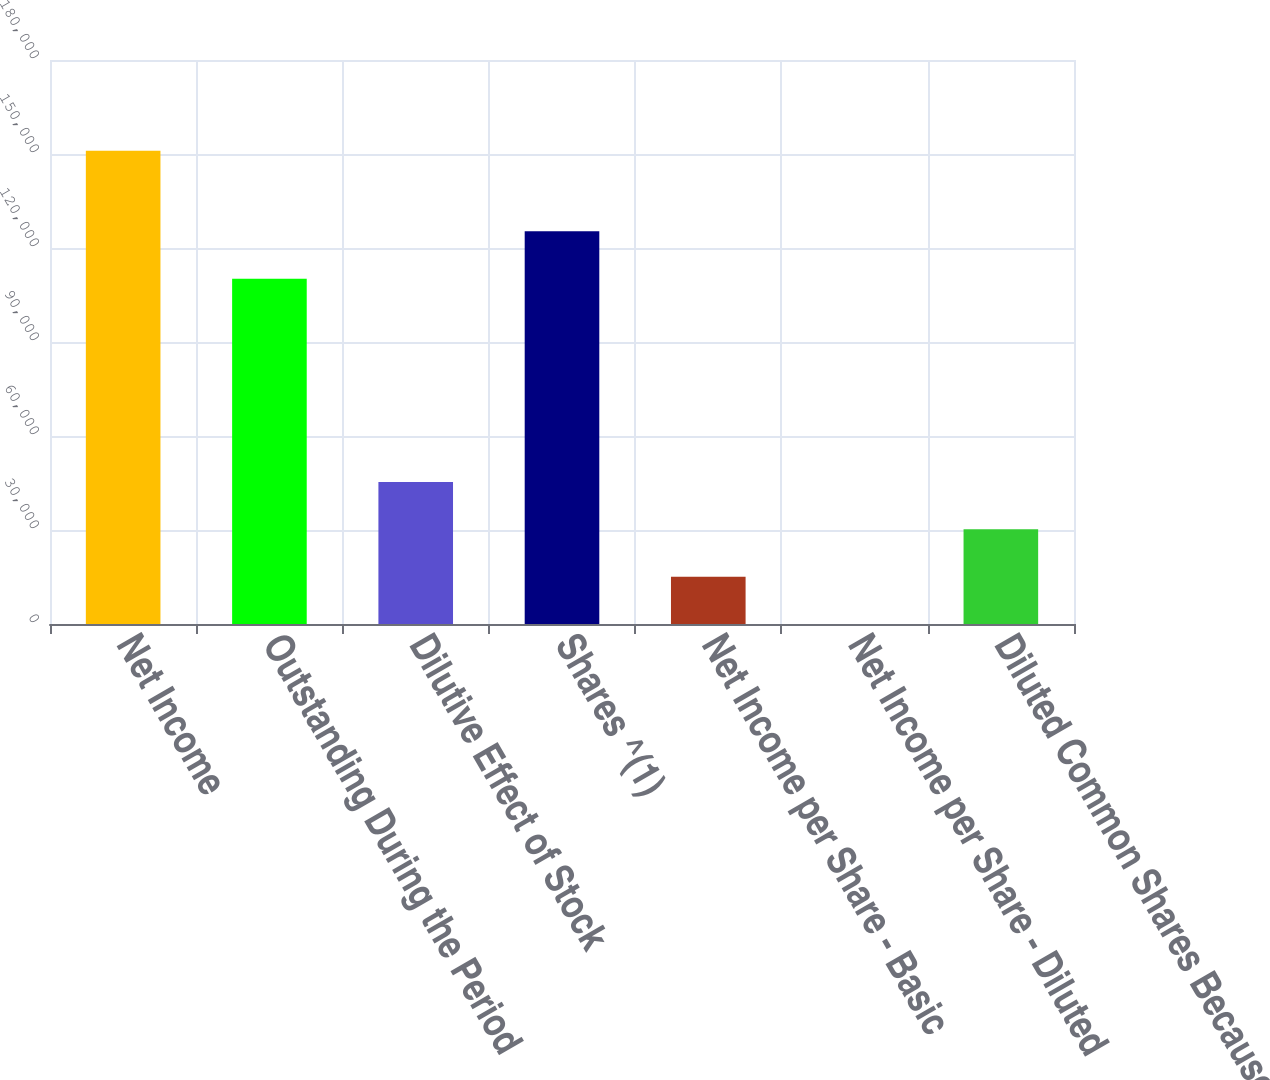Convert chart to OTSL. <chart><loc_0><loc_0><loc_500><loc_500><bar_chart><fcel>Net Income<fcel>Outstanding During the Period<fcel>Dilutive Effect of Stock<fcel>Shares ^(1)<fcel>Net Income per Share - Basic<fcel>Net Income per Share - Diluted<fcel>Diluted Common Shares Because<nl><fcel>151046<fcel>110217<fcel>45314.7<fcel>125321<fcel>15105.8<fcel>1.33<fcel>30210.3<nl></chart> 